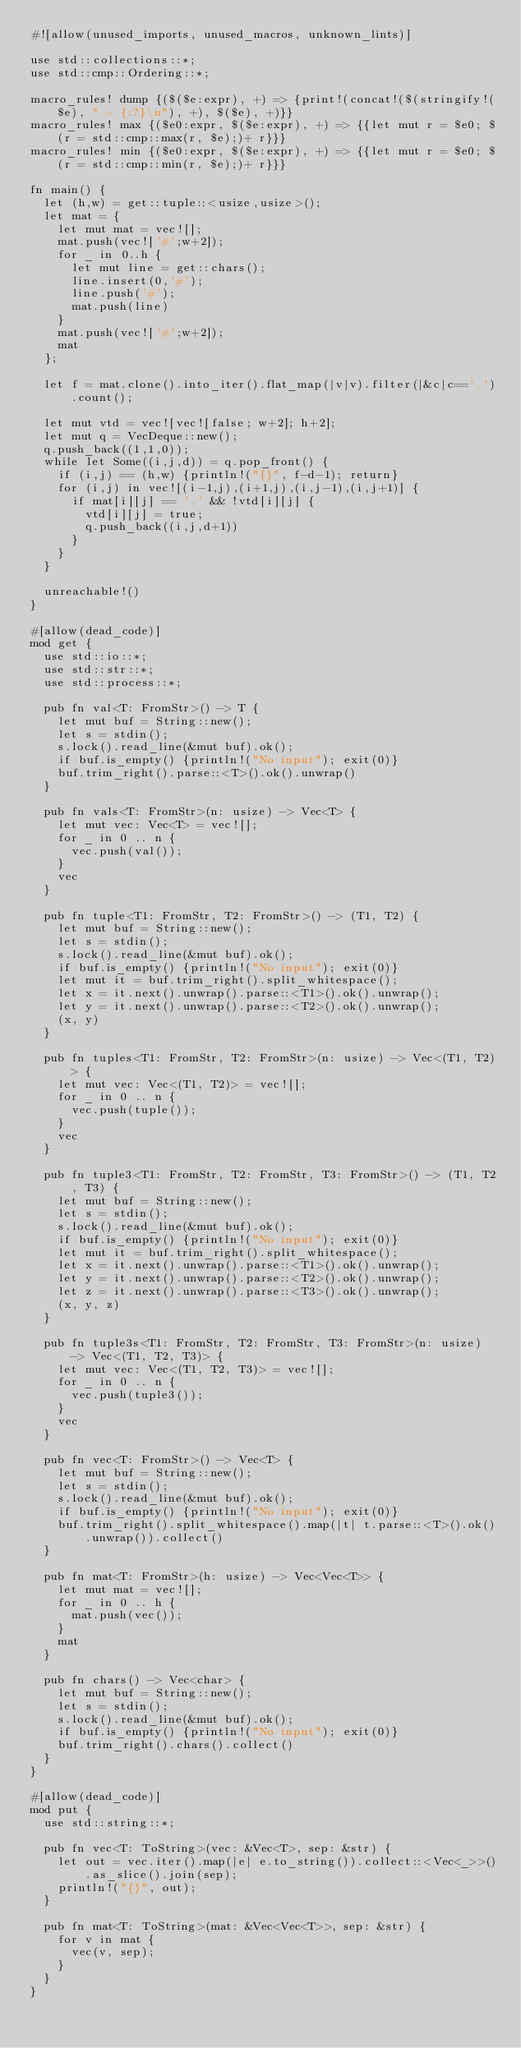<code> <loc_0><loc_0><loc_500><loc_500><_Rust_>#![allow(unused_imports, unused_macros, unknown_lints)]

use std::collections::*;
use std::cmp::Ordering::*;

macro_rules! dump {($($e:expr), +) => {print!(concat!($(stringify!($e), " = {:?}\n"), +), $($e), +)}}
macro_rules! max {($e0:expr, $($e:expr), +) => {{let mut r = $e0; $(r = std::cmp::max(r, $e);)+ r}}}
macro_rules! min {($e0:expr, $($e:expr), +) => {{let mut r = $e0; $(r = std::cmp::min(r, $e);)+ r}}}

fn main() {
  let (h,w) = get::tuple::<usize,usize>();
  let mat = {
    let mut mat = vec![];
    mat.push(vec!['#';w+2]);
    for _ in 0..h {
      let mut line = get::chars();
      line.insert(0,'#');
      line.push('#');
      mat.push(line)
    }
    mat.push(vec!['#';w+2]);
    mat
  };

  let f = mat.clone().into_iter().flat_map(|v|v).filter(|&c|c=='.').count();

  let mut vtd = vec![vec![false; w+2]; h+2];
  let mut q = VecDeque::new();
  q.push_back((1,1,0));
  while let Some((i,j,d)) = q.pop_front() {
    if (i,j) == (h,w) {println!("{}", f-d-1); return}
    for (i,j) in vec![(i-1,j),(i+1,j),(i,j-1),(i,j+1)] {
      if mat[i][j] == '.' && !vtd[i][j] {
        vtd[i][j] = true;
        q.push_back((i,j,d+1))
      }
    }
  }

  unreachable!()
}

#[allow(dead_code)]
mod get {
  use std::io::*;
  use std::str::*;
  use std::process::*;

  pub fn val<T: FromStr>() -> T {
    let mut buf = String::new();
    let s = stdin();
    s.lock().read_line(&mut buf).ok();
    if buf.is_empty() {println!("No input"); exit(0)}
    buf.trim_right().parse::<T>().ok().unwrap()
  }

  pub fn vals<T: FromStr>(n: usize) -> Vec<T> {
    let mut vec: Vec<T> = vec![];
    for _ in 0 .. n {
      vec.push(val());
    }
    vec
  }

  pub fn tuple<T1: FromStr, T2: FromStr>() -> (T1, T2) {
    let mut buf = String::new();
    let s = stdin();
    s.lock().read_line(&mut buf).ok();
    if buf.is_empty() {println!("No input"); exit(0)}
    let mut it = buf.trim_right().split_whitespace();
    let x = it.next().unwrap().parse::<T1>().ok().unwrap();
    let y = it.next().unwrap().parse::<T2>().ok().unwrap();
    (x, y)
  }

  pub fn tuples<T1: FromStr, T2: FromStr>(n: usize) -> Vec<(T1, T2)> {
    let mut vec: Vec<(T1, T2)> = vec![];
    for _ in 0 .. n {
      vec.push(tuple());
    }
    vec
  }

  pub fn tuple3<T1: FromStr, T2: FromStr, T3: FromStr>() -> (T1, T2, T3) {
    let mut buf = String::new();
    let s = stdin();
    s.lock().read_line(&mut buf).ok();
    if buf.is_empty() {println!("No input"); exit(0)}
    let mut it = buf.trim_right().split_whitespace();
    let x = it.next().unwrap().parse::<T1>().ok().unwrap();
    let y = it.next().unwrap().parse::<T2>().ok().unwrap();
    let z = it.next().unwrap().parse::<T3>().ok().unwrap();
    (x, y, z)
  }

  pub fn tuple3s<T1: FromStr, T2: FromStr, T3: FromStr>(n: usize) -> Vec<(T1, T2, T3)> {
    let mut vec: Vec<(T1, T2, T3)> = vec![];
    for _ in 0 .. n {
      vec.push(tuple3());
    }
    vec
  }

  pub fn vec<T: FromStr>() -> Vec<T> {
    let mut buf = String::new();
    let s = stdin();
    s.lock().read_line(&mut buf).ok();
    if buf.is_empty() {println!("No input"); exit(0)}
    buf.trim_right().split_whitespace().map(|t| t.parse::<T>().ok().unwrap()).collect()
  }

  pub fn mat<T: FromStr>(h: usize) -> Vec<Vec<T>> {
    let mut mat = vec![];
    for _ in 0 .. h {
      mat.push(vec());
    }
    mat
  }

  pub fn chars() -> Vec<char> {
    let mut buf = String::new();
    let s = stdin();
    s.lock().read_line(&mut buf).ok();
    if buf.is_empty() {println!("No input"); exit(0)}
    buf.trim_right().chars().collect()
  }
}

#[allow(dead_code)]
mod put {
  use std::string::*;

  pub fn vec<T: ToString>(vec: &Vec<T>, sep: &str) {
    let out = vec.iter().map(|e| e.to_string()).collect::<Vec<_>>().as_slice().join(sep);
    println!("{}", out);
  }

  pub fn mat<T: ToString>(mat: &Vec<Vec<T>>, sep: &str) {
    for v in mat {
      vec(v, sep);
    }
  }
}</code> 